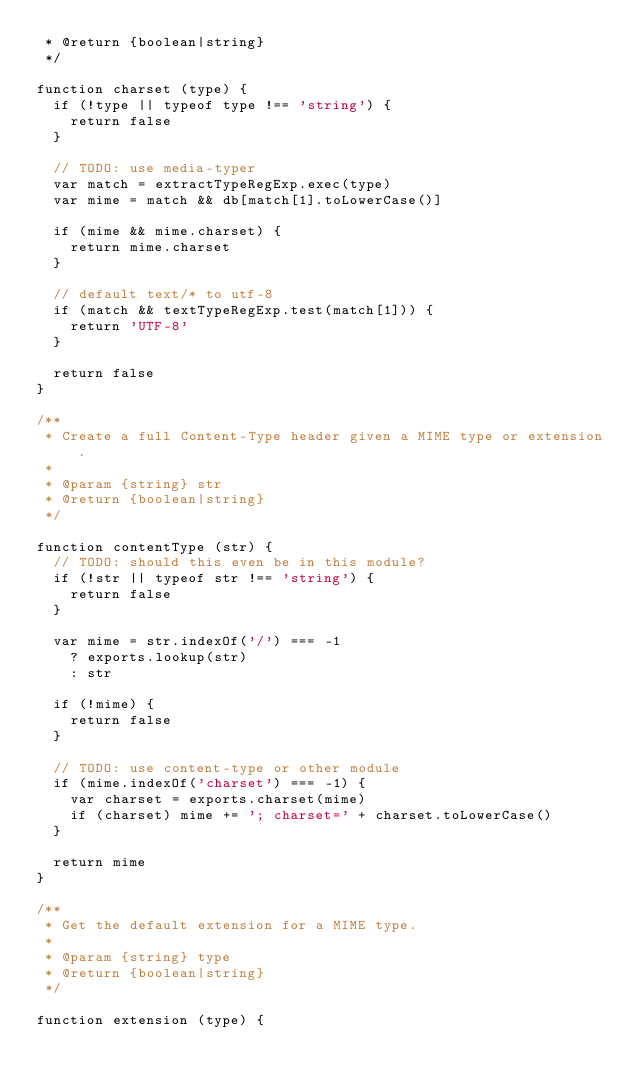<code> <loc_0><loc_0><loc_500><loc_500><_JavaScript_> * @return {boolean|string}
 */

function charset (type) {
  if (!type || typeof type !== 'string') {
    return false
  }

  // TODO: use media-typer
  var match = extractTypeRegExp.exec(type)
  var mime = match && db[match[1].toLowerCase()]

  if (mime && mime.charset) {
    return mime.charset
  }

  // default text/* to utf-8
  if (match && textTypeRegExp.test(match[1])) {
    return 'UTF-8'
  }

  return false
}

/**
 * Create a full Content-Type header given a MIME type or extension.
 *
 * @param {string} str
 * @return {boolean|string}
 */

function contentType (str) {
  // TODO: should this even be in this module?
  if (!str || typeof str !== 'string') {
    return false
  }

  var mime = str.indexOf('/') === -1
    ? exports.lookup(str)
    : str

  if (!mime) {
    return false
  }

  // TODO: use content-type or other module
  if (mime.indexOf('charset') === -1) {
    var charset = exports.charset(mime)
    if (charset) mime += '; charset=' + charset.toLowerCase()
  }

  return mime
}

/**
 * Get the default extension for a MIME type.
 *
 * @param {string} type
 * @return {boolean|string}
 */

function extension (type) {</code> 